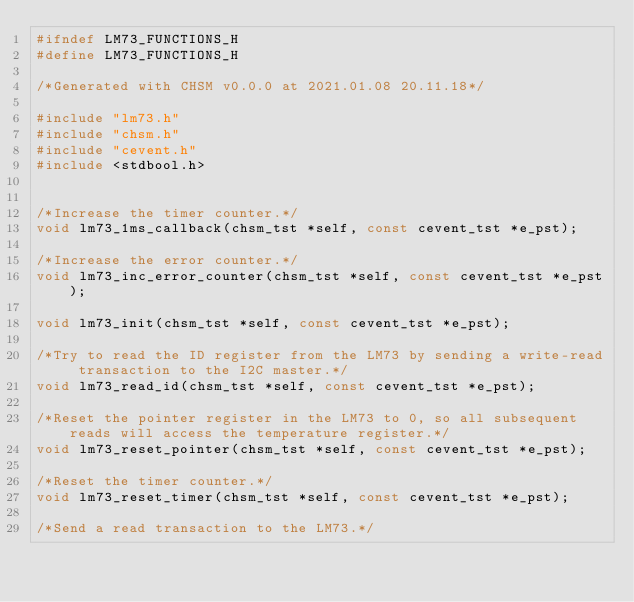Convert code to text. <code><loc_0><loc_0><loc_500><loc_500><_C_>#ifndef LM73_FUNCTIONS_H
#define LM73_FUNCTIONS_H

/*Generated with CHSM v0.0.0 at 2021.01.08 20.11.18*/

#include "lm73.h"
#include "chsm.h"
#include "cevent.h"
#include <stdbool.h>


/*Increase the timer counter.*/
void lm73_1ms_callback(chsm_tst *self, const cevent_tst *e_pst);

/*Increase the error counter.*/
void lm73_inc_error_counter(chsm_tst *self, const cevent_tst *e_pst);

void lm73_init(chsm_tst *self, const cevent_tst *e_pst);

/*Try to read the ID register from the LM73 by sending a write-read transaction to the I2C master.*/
void lm73_read_id(chsm_tst *self, const cevent_tst *e_pst);

/*Reset the pointer register in the LM73 to 0, so all subsequent reads will access the temperature register.*/
void lm73_reset_pointer(chsm_tst *self, const cevent_tst *e_pst);

/*Reset the timer counter.*/
void lm73_reset_timer(chsm_tst *self, const cevent_tst *e_pst);

/*Send a read transaction to the LM73.*/</code> 